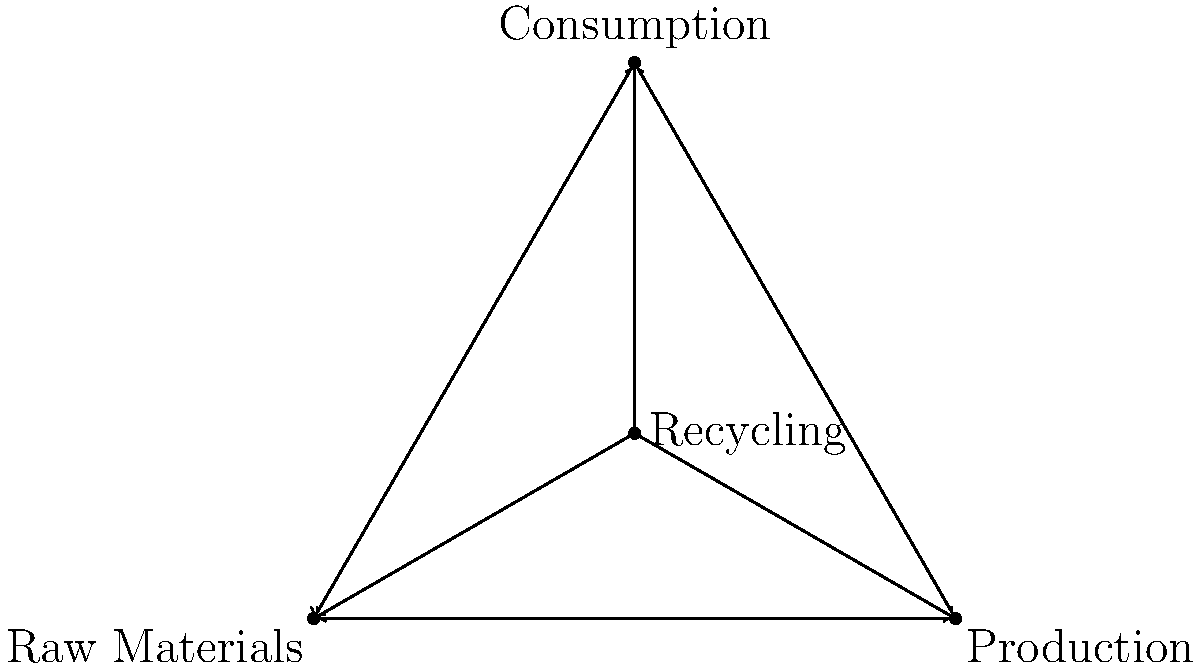In the circular economy model shown, which stage is crucial for minimizing waste and ensuring the continuous flow of materials back into the system? To answer this question, let's analyze the circular economy model step-by-step:

1. The model shows four main stages: Raw Materials, Production, Consumption, and Recycling.

2. Raw Materials (bottom left): This is the starting point of the cycle, where resources enter the system.

3. Production (bottom right): Raw materials are transformed into products.

4. Consumption (top): Products are used by consumers.

5. Recycling (center): This stage is connected to all other stages with bidirectional arrows.

6. The key to minimizing waste and ensuring continuous flow of materials is the stage that connects back to raw materials and production.

7. Recycling serves this crucial function by:
   a) Collecting used materials from the consumption stage
   b) Processing these materials to make them suitable for reuse
   c) Feeding these recycled materials back into raw materials or directly into production

8. Without effective recycling, the model would be linear (raw materials → production → consumption → waste) rather than circular.

Therefore, the recycling stage is crucial for minimizing waste and ensuring the continuous flow of materials back into the system in this circular economy model.
Answer: Recycling 